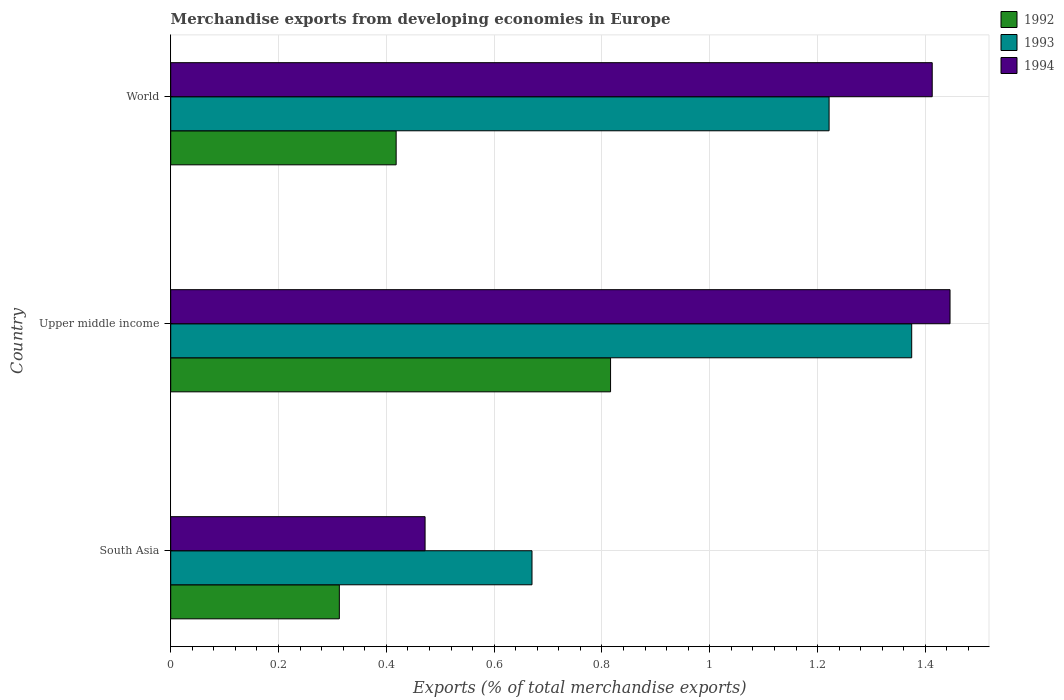How many different coloured bars are there?
Make the answer very short. 3. How many groups of bars are there?
Give a very brief answer. 3. Are the number of bars per tick equal to the number of legend labels?
Offer a very short reply. Yes. What is the label of the 2nd group of bars from the top?
Give a very brief answer. Upper middle income. What is the percentage of total merchandise exports in 1993 in South Asia?
Make the answer very short. 0.67. Across all countries, what is the maximum percentage of total merchandise exports in 1993?
Keep it short and to the point. 1.37. Across all countries, what is the minimum percentage of total merchandise exports in 1994?
Your answer should be compact. 0.47. In which country was the percentage of total merchandise exports in 1994 maximum?
Provide a short and direct response. Upper middle income. What is the total percentage of total merchandise exports in 1994 in the graph?
Make the answer very short. 3.33. What is the difference between the percentage of total merchandise exports in 1992 in Upper middle income and that in World?
Offer a very short reply. 0.4. What is the difference between the percentage of total merchandise exports in 1994 in South Asia and the percentage of total merchandise exports in 1992 in World?
Your response must be concise. 0.05. What is the average percentage of total merchandise exports in 1994 per country?
Your answer should be compact. 1.11. What is the difference between the percentage of total merchandise exports in 1994 and percentage of total merchandise exports in 1993 in World?
Provide a short and direct response. 0.19. In how many countries, is the percentage of total merchandise exports in 1994 greater than 0.9600000000000001 %?
Offer a terse response. 2. What is the ratio of the percentage of total merchandise exports in 1994 in South Asia to that in Upper middle income?
Provide a short and direct response. 0.33. Is the percentage of total merchandise exports in 1994 in South Asia less than that in Upper middle income?
Your answer should be compact. Yes. What is the difference between the highest and the second highest percentage of total merchandise exports in 1992?
Make the answer very short. 0.4. What is the difference between the highest and the lowest percentage of total merchandise exports in 1992?
Your answer should be very brief. 0.5. In how many countries, is the percentage of total merchandise exports in 1993 greater than the average percentage of total merchandise exports in 1993 taken over all countries?
Offer a very short reply. 2. Is the sum of the percentage of total merchandise exports in 1992 in South Asia and World greater than the maximum percentage of total merchandise exports in 1994 across all countries?
Offer a terse response. No. What does the 2nd bar from the top in World represents?
Offer a terse response. 1993. What does the 1st bar from the bottom in Upper middle income represents?
Keep it short and to the point. 1992. Is it the case that in every country, the sum of the percentage of total merchandise exports in 1993 and percentage of total merchandise exports in 1994 is greater than the percentage of total merchandise exports in 1992?
Ensure brevity in your answer.  Yes. How many bars are there?
Your response must be concise. 9. Are all the bars in the graph horizontal?
Your answer should be compact. Yes. How many countries are there in the graph?
Your response must be concise. 3. Does the graph contain grids?
Your answer should be compact. Yes. Where does the legend appear in the graph?
Make the answer very short. Top right. How many legend labels are there?
Keep it short and to the point. 3. How are the legend labels stacked?
Your answer should be very brief. Vertical. What is the title of the graph?
Keep it short and to the point. Merchandise exports from developing economies in Europe. Does "1972" appear as one of the legend labels in the graph?
Keep it short and to the point. No. What is the label or title of the X-axis?
Provide a short and direct response. Exports (% of total merchandise exports). What is the Exports (% of total merchandise exports) in 1992 in South Asia?
Your answer should be compact. 0.31. What is the Exports (% of total merchandise exports) of 1993 in South Asia?
Give a very brief answer. 0.67. What is the Exports (% of total merchandise exports) of 1994 in South Asia?
Your answer should be very brief. 0.47. What is the Exports (% of total merchandise exports) in 1992 in Upper middle income?
Offer a very short reply. 0.82. What is the Exports (% of total merchandise exports) in 1993 in Upper middle income?
Provide a succinct answer. 1.37. What is the Exports (% of total merchandise exports) of 1994 in Upper middle income?
Your answer should be very brief. 1.45. What is the Exports (% of total merchandise exports) in 1992 in World?
Your response must be concise. 0.42. What is the Exports (% of total merchandise exports) in 1993 in World?
Offer a terse response. 1.22. What is the Exports (% of total merchandise exports) in 1994 in World?
Give a very brief answer. 1.41. Across all countries, what is the maximum Exports (% of total merchandise exports) of 1992?
Offer a very short reply. 0.82. Across all countries, what is the maximum Exports (% of total merchandise exports) of 1993?
Provide a short and direct response. 1.37. Across all countries, what is the maximum Exports (% of total merchandise exports) of 1994?
Make the answer very short. 1.45. Across all countries, what is the minimum Exports (% of total merchandise exports) of 1992?
Your answer should be compact. 0.31. Across all countries, what is the minimum Exports (% of total merchandise exports) in 1993?
Give a very brief answer. 0.67. Across all countries, what is the minimum Exports (% of total merchandise exports) in 1994?
Offer a very short reply. 0.47. What is the total Exports (% of total merchandise exports) of 1992 in the graph?
Your answer should be very brief. 1.55. What is the total Exports (% of total merchandise exports) of 1993 in the graph?
Your answer should be very brief. 3.27. What is the total Exports (% of total merchandise exports) of 1994 in the graph?
Ensure brevity in your answer.  3.33. What is the difference between the Exports (% of total merchandise exports) of 1992 in South Asia and that in Upper middle income?
Your answer should be compact. -0.5. What is the difference between the Exports (% of total merchandise exports) of 1993 in South Asia and that in Upper middle income?
Ensure brevity in your answer.  -0.7. What is the difference between the Exports (% of total merchandise exports) in 1994 in South Asia and that in Upper middle income?
Your answer should be compact. -0.97. What is the difference between the Exports (% of total merchandise exports) in 1992 in South Asia and that in World?
Make the answer very short. -0.11. What is the difference between the Exports (% of total merchandise exports) in 1993 in South Asia and that in World?
Offer a terse response. -0.55. What is the difference between the Exports (% of total merchandise exports) in 1994 in South Asia and that in World?
Your answer should be compact. -0.94. What is the difference between the Exports (% of total merchandise exports) of 1992 in Upper middle income and that in World?
Offer a terse response. 0.4. What is the difference between the Exports (% of total merchandise exports) of 1993 in Upper middle income and that in World?
Offer a very short reply. 0.15. What is the difference between the Exports (% of total merchandise exports) of 1994 in Upper middle income and that in World?
Offer a terse response. 0.03. What is the difference between the Exports (% of total merchandise exports) of 1992 in South Asia and the Exports (% of total merchandise exports) of 1993 in Upper middle income?
Offer a terse response. -1.06. What is the difference between the Exports (% of total merchandise exports) in 1992 in South Asia and the Exports (% of total merchandise exports) in 1994 in Upper middle income?
Your answer should be very brief. -1.13. What is the difference between the Exports (% of total merchandise exports) of 1993 in South Asia and the Exports (% of total merchandise exports) of 1994 in Upper middle income?
Provide a short and direct response. -0.78. What is the difference between the Exports (% of total merchandise exports) in 1992 in South Asia and the Exports (% of total merchandise exports) in 1993 in World?
Keep it short and to the point. -0.91. What is the difference between the Exports (% of total merchandise exports) of 1992 in South Asia and the Exports (% of total merchandise exports) of 1994 in World?
Provide a succinct answer. -1.1. What is the difference between the Exports (% of total merchandise exports) of 1993 in South Asia and the Exports (% of total merchandise exports) of 1994 in World?
Keep it short and to the point. -0.74. What is the difference between the Exports (% of total merchandise exports) in 1992 in Upper middle income and the Exports (% of total merchandise exports) in 1993 in World?
Provide a short and direct response. -0.41. What is the difference between the Exports (% of total merchandise exports) of 1992 in Upper middle income and the Exports (% of total merchandise exports) of 1994 in World?
Keep it short and to the point. -0.6. What is the difference between the Exports (% of total merchandise exports) in 1993 in Upper middle income and the Exports (% of total merchandise exports) in 1994 in World?
Provide a short and direct response. -0.04. What is the average Exports (% of total merchandise exports) in 1992 per country?
Your answer should be very brief. 0.52. What is the average Exports (% of total merchandise exports) in 1993 per country?
Offer a terse response. 1.09. What is the average Exports (% of total merchandise exports) of 1994 per country?
Offer a very short reply. 1.11. What is the difference between the Exports (% of total merchandise exports) in 1992 and Exports (% of total merchandise exports) in 1993 in South Asia?
Your response must be concise. -0.36. What is the difference between the Exports (% of total merchandise exports) of 1992 and Exports (% of total merchandise exports) of 1994 in South Asia?
Provide a short and direct response. -0.16. What is the difference between the Exports (% of total merchandise exports) in 1993 and Exports (% of total merchandise exports) in 1994 in South Asia?
Offer a very short reply. 0.2. What is the difference between the Exports (% of total merchandise exports) of 1992 and Exports (% of total merchandise exports) of 1993 in Upper middle income?
Keep it short and to the point. -0.56. What is the difference between the Exports (% of total merchandise exports) in 1992 and Exports (% of total merchandise exports) in 1994 in Upper middle income?
Provide a short and direct response. -0.63. What is the difference between the Exports (% of total merchandise exports) in 1993 and Exports (% of total merchandise exports) in 1994 in Upper middle income?
Offer a terse response. -0.07. What is the difference between the Exports (% of total merchandise exports) in 1992 and Exports (% of total merchandise exports) in 1993 in World?
Offer a terse response. -0.8. What is the difference between the Exports (% of total merchandise exports) in 1992 and Exports (% of total merchandise exports) in 1994 in World?
Provide a short and direct response. -0.99. What is the difference between the Exports (% of total merchandise exports) of 1993 and Exports (% of total merchandise exports) of 1994 in World?
Offer a terse response. -0.19. What is the ratio of the Exports (% of total merchandise exports) in 1992 in South Asia to that in Upper middle income?
Provide a succinct answer. 0.38. What is the ratio of the Exports (% of total merchandise exports) in 1993 in South Asia to that in Upper middle income?
Provide a short and direct response. 0.49. What is the ratio of the Exports (% of total merchandise exports) of 1994 in South Asia to that in Upper middle income?
Keep it short and to the point. 0.33. What is the ratio of the Exports (% of total merchandise exports) in 1992 in South Asia to that in World?
Offer a very short reply. 0.75. What is the ratio of the Exports (% of total merchandise exports) of 1993 in South Asia to that in World?
Your response must be concise. 0.55. What is the ratio of the Exports (% of total merchandise exports) in 1994 in South Asia to that in World?
Make the answer very short. 0.33. What is the ratio of the Exports (% of total merchandise exports) in 1992 in Upper middle income to that in World?
Your answer should be very brief. 1.95. What is the ratio of the Exports (% of total merchandise exports) in 1993 in Upper middle income to that in World?
Provide a succinct answer. 1.13. What is the ratio of the Exports (% of total merchandise exports) of 1994 in Upper middle income to that in World?
Make the answer very short. 1.02. What is the difference between the highest and the second highest Exports (% of total merchandise exports) of 1992?
Make the answer very short. 0.4. What is the difference between the highest and the second highest Exports (% of total merchandise exports) of 1993?
Give a very brief answer. 0.15. What is the difference between the highest and the second highest Exports (% of total merchandise exports) in 1994?
Ensure brevity in your answer.  0.03. What is the difference between the highest and the lowest Exports (% of total merchandise exports) in 1992?
Give a very brief answer. 0.5. What is the difference between the highest and the lowest Exports (% of total merchandise exports) in 1993?
Provide a succinct answer. 0.7. What is the difference between the highest and the lowest Exports (% of total merchandise exports) in 1994?
Offer a terse response. 0.97. 